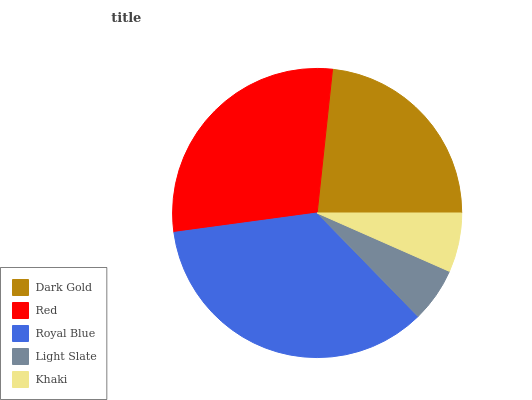Is Light Slate the minimum?
Answer yes or no. Yes. Is Royal Blue the maximum?
Answer yes or no. Yes. Is Red the minimum?
Answer yes or no. No. Is Red the maximum?
Answer yes or no. No. Is Red greater than Dark Gold?
Answer yes or no. Yes. Is Dark Gold less than Red?
Answer yes or no. Yes. Is Dark Gold greater than Red?
Answer yes or no. No. Is Red less than Dark Gold?
Answer yes or no. No. Is Dark Gold the high median?
Answer yes or no. Yes. Is Dark Gold the low median?
Answer yes or no. Yes. Is Royal Blue the high median?
Answer yes or no. No. Is Red the low median?
Answer yes or no. No. 